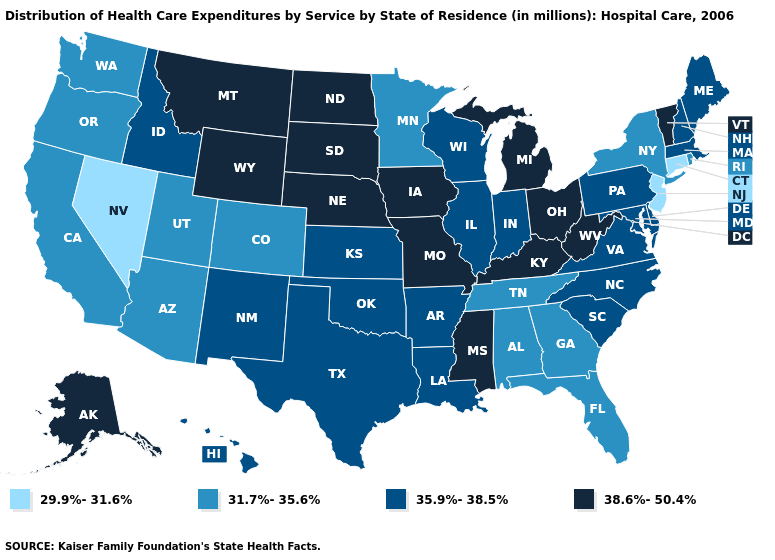What is the highest value in the USA?
Be succinct. 38.6%-50.4%. Does Iowa have the highest value in the USA?
Give a very brief answer. Yes. How many symbols are there in the legend?
Concise answer only. 4. Does West Virginia have the highest value in the South?
Answer briefly. Yes. Which states have the lowest value in the USA?
Quick response, please. Connecticut, Nevada, New Jersey. What is the value of Delaware?
Give a very brief answer. 35.9%-38.5%. Does Alaska have the highest value in the USA?
Keep it brief. Yes. Does Idaho have a higher value than Missouri?
Quick response, please. No. Name the states that have a value in the range 38.6%-50.4%?
Give a very brief answer. Alaska, Iowa, Kentucky, Michigan, Mississippi, Missouri, Montana, Nebraska, North Dakota, Ohio, South Dakota, Vermont, West Virginia, Wyoming. Does the first symbol in the legend represent the smallest category?
Concise answer only. Yes. What is the lowest value in states that border Utah?
Short answer required. 29.9%-31.6%. Name the states that have a value in the range 29.9%-31.6%?
Be succinct. Connecticut, Nevada, New Jersey. What is the highest value in the South ?
Quick response, please. 38.6%-50.4%. Among the states that border Missouri , which have the highest value?
Answer briefly. Iowa, Kentucky, Nebraska. What is the value of South Carolina?
Give a very brief answer. 35.9%-38.5%. 